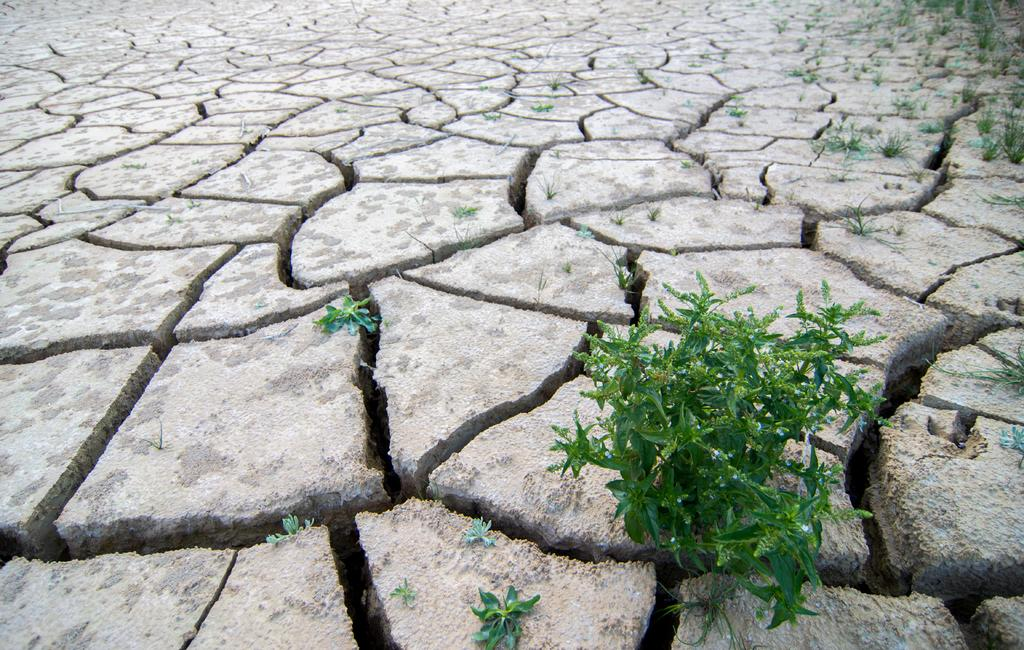What type of surface is visible in the image? There is ground visible in the image. What is a notable feature of the ground? There are cracks on the ground. What type of vegetation can be seen in the image? There are green plants and grass in the image. What type of juice is being served by the queen in the image? There is no queen or juice present in the image. What type of land is depicted in the image? The image does not depict a specific type of land; it simply shows ground with cracks and vegetation. 